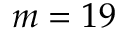<formula> <loc_0><loc_0><loc_500><loc_500>m = 1 9</formula> 